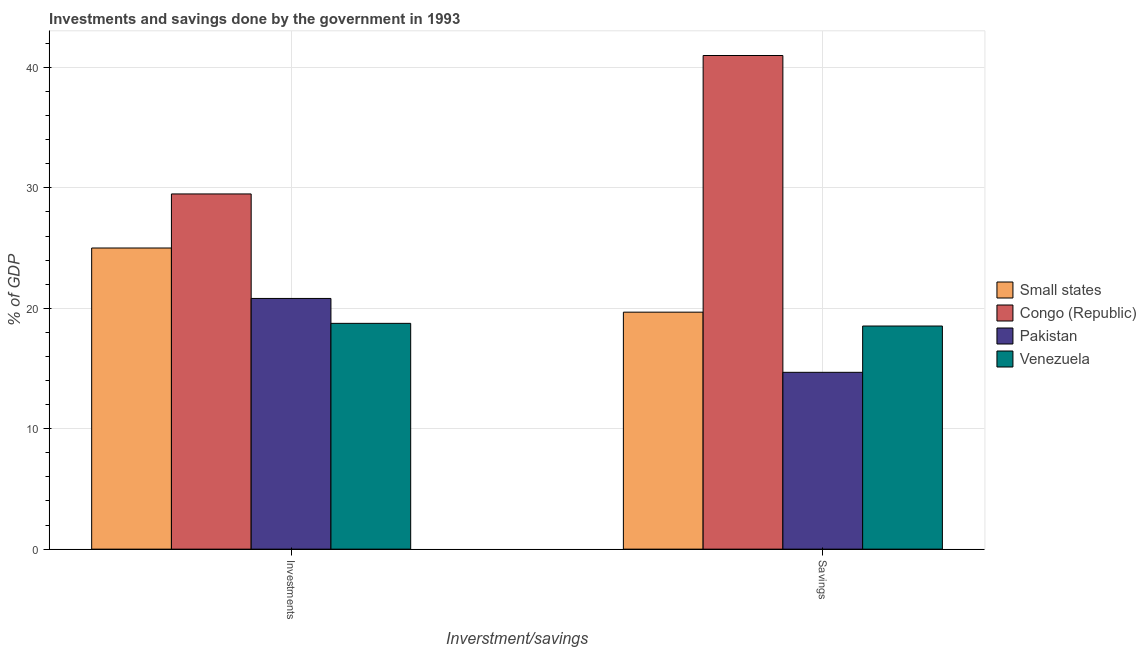How many groups of bars are there?
Your answer should be compact. 2. Are the number of bars per tick equal to the number of legend labels?
Make the answer very short. Yes. How many bars are there on the 1st tick from the left?
Your response must be concise. 4. How many bars are there on the 2nd tick from the right?
Make the answer very short. 4. What is the label of the 1st group of bars from the left?
Ensure brevity in your answer.  Investments. What is the savings of government in Small states?
Your answer should be compact. 19.68. Across all countries, what is the maximum investments of government?
Your answer should be compact. 29.5. Across all countries, what is the minimum savings of government?
Give a very brief answer. 14.68. In which country was the savings of government maximum?
Offer a terse response. Congo (Republic). What is the total investments of government in the graph?
Your answer should be compact. 94.07. What is the difference between the investments of government in Small states and that in Pakistan?
Offer a terse response. 4.19. What is the difference between the savings of government in Small states and the investments of government in Congo (Republic)?
Provide a succinct answer. -9.82. What is the average investments of government per country?
Provide a succinct answer. 23.52. What is the difference between the savings of government and investments of government in Congo (Republic)?
Provide a short and direct response. 11.5. In how many countries, is the savings of government greater than 30 %?
Provide a succinct answer. 1. What is the ratio of the investments of government in Venezuela to that in Small states?
Your response must be concise. 0.75. Is the investments of government in Small states less than that in Pakistan?
Ensure brevity in your answer.  No. What does the 4th bar from the left in Savings represents?
Provide a short and direct response. Venezuela. What does the 2nd bar from the right in Savings represents?
Your response must be concise. Pakistan. How many countries are there in the graph?
Your answer should be compact. 4. What is the difference between two consecutive major ticks on the Y-axis?
Make the answer very short. 10. Where does the legend appear in the graph?
Provide a short and direct response. Center right. How many legend labels are there?
Offer a very short reply. 4. How are the legend labels stacked?
Provide a short and direct response. Vertical. What is the title of the graph?
Your response must be concise. Investments and savings done by the government in 1993. What is the label or title of the X-axis?
Your answer should be compact. Inverstment/savings. What is the label or title of the Y-axis?
Give a very brief answer. % of GDP. What is the % of GDP of Small states in Investments?
Ensure brevity in your answer.  25.01. What is the % of GDP in Congo (Republic) in Investments?
Ensure brevity in your answer.  29.5. What is the % of GDP in Pakistan in Investments?
Your answer should be very brief. 20.82. What is the % of GDP of Venezuela in Investments?
Offer a very short reply. 18.75. What is the % of GDP of Small states in Savings?
Keep it short and to the point. 19.68. What is the % of GDP in Congo (Republic) in Savings?
Keep it short and to the point. 40.99. What is the % of GDP of Pakistan in Savings?
Keep it short and to the point. 14.68. What is the % of GDP in Venezuela in Savings?
Your answer should be compact. 18.53. Across all Inverstment/savings, what is the maximum % of GDP of Small states?
Ensure brevity in your answer.  25.01. Across all Inverstment/savings, what is the maximum % of GDP in Congo (Republic)?
Offer a terse response. 40.99. Across all Inverstment/savings, what is the maximum % of GDP in Pakistan?
Offer a terse response. 20.82. Across all Inverstment/savings, what is the maximum % of GDP in Venezuela?
Ensure brevity in your answer.  18.75. Across all Inverstment/savings, what is the minimum % of GDP of Small states?
Keep it short and to the point. 19.68. Across all Inverstment/savings, what is the minimum % of GDP of Congo (Republic)?
Keep it short and to the point. 29.5. Across all Inverstment/savings, what is the minimum % of GDP of Pakistan?
Keep it short and to the point. 14.68. Across all Inverstment/savings, what is the minimum % of GDP of Venezuela?
Offer a terse response. 18.53. What is the total % of GDP in Small states in the graph?
Make the answer very short. 44.69. What is the total % of GDP in Congo (Republic) in the graph?
Your response must be concise. 70.49. What is the total % of GDP in Pakistan in the graph?
Ensure brevity in your answer.  35.5. What is the total % of GDP in Venezuela in the graph?
Provide a short and direct response. 37.28. What is the difference between the % of GDP of Small states in Investments and that in Savings?
Ensure brevity in your answer.  5.33. What is the difference between the % of GDP in Congo (Republic) in Investments and that in Savings?
Your response must be concise. -11.5. What is the difference between the % of GDP in Pakistan in Investments and that in Savings?
Your answer should be compact. 6.13. What is the difference between the % of GDP of Venezuela in Investments and that in Savings?
Your answer should be compact. 0.22. What is the difference between the % of GDP of Small states in Investments and the % of GDP of Congo (Republic) in Savings?
Provide a succinct answer. -15.98. What is the difference between the % of GDP in Small states in Investments and the % of GDP in Pakistan in Savings?
Provide a short and direct response. 10.32. What is the difference between the % of GDP in Small states in Investments and the % of GDP in Venezuela in Savings?
Offer a terse response. 6.48. What is the difference between the % of GDP in Congo (Republic) in Investments and the % of GDP in Pakistan in Savings?
Keep it short and to the point. 14.81. What is the difference between the % of GDP in Congo (Republic) in Investments and the % of GDP in Venezuela in Savings?
Provide a short and direct response. 10.97. What is the difference between the % of GDP in Pakistan in Investments and the % of GDP in Venezuela in Savings?
Your answer should be very brief. 2.29. What is the average % of GDP of Small states per Inverstment/savings?
Offer a terse response. 22.34. What is the average % of GDP in Congo (Republic) per Inverstment/savings?
Keep it short and to the point. 35.24. What is the average % of GDP of Pakistan per Inverstment/savings?
Provide a succinct answer. 17.75. What is the average % of GDP of Venezuela per Inverstment/savings?
Give a very brief answer. 18.64. What is the difference between the % of GDP of Small states and % of GDP of Congo (Republic) in Investments?
Your answer should be compact. -4.49. What is the difference between the % of GDP in Small states and % of GDP in Pakistan in Investments?
Your answer should be very brief. 4.19. What is the difference between the % of GDP in Small states and % of GDP in Venezuela in Investments?
Offer a very short reply. 6.26. What is the difference between the % of GDP of Congo (Republic) and % of GDP of Pakistan in Investments?
Ensure brevity in your answer.  8.68. What is the difference between the % of GDP of Congo (Republic) and % of GDP of Venezuela in Investments?
Your answer should be compact. 10.75. What is the difference between the % of GDP in Pakistan and % of GDP in Venezuela in Investments?
Offer a very short reply. 2.07. What is the difference between the % of GDP of Small states and % of GDP of Congo (Republic) in Savings?
Give a very brief answer. -21.31. What is the difference between the % of GDP of Small states and % of GDP of Pakistan in Savings?
Give a very brief answer. 5. What is the difference between the % of GDP in Small states and % of GDP in Venezuela in Savings?
Make the answer very short. 1.15. What is the difference between the % of GDP in Congo (Republic) and % of GDP in Pakistan in Savings?
Your answer should be very brief. 26.31. What is the difference between the % of GDP in Congo (Republic) and % of GDP in Venezuela in Savings?
Give a very brief answer. 22.46. What is the difference between the % of GDP in Pakistan and % of GDP in Venezuela in Savings?
Offer a very short reply. -3.84. What is the ratio of the % of GDP of Small states in Investments to that in Savings?
Give a very brief answer. 1.27. What is the ratio of the % of GDP in Congo (Republic) in Investments to that in Savings?
Your response must be concise. 0.72. What is the ratio of the % of GDP in Pakistan in Investments to that in Savings?
Your answer should be very brief. 1.42. What is the ratio of the % of GDP of Venezuela in Investments to that in Savings?
Your answer should be compact. 1.01. What is the difference between the highest and the second highest % of GDP in Small states?
Offer a terse response. 5.33. What is the difference between the highest and the second highest % of GDP in Congo (Republic)?
Offer a terse response. 11.5. What is the difference between the highest and the second highest % of GDP in Pakistan?
Provide a short and direct response. 6.13. What is the difference between the highest and the second highest % of GDP of Venezuela?
Make the answer very short. 0.22. What is the difference between the highest and the lowest % of GDP of Small states?
Provide a short and direct response. 5.33. What is the difference between the highest and the lowest % of GDP in Congo (Republic)?
Make the answer very short. 11.5. What is the difference between the highest and the lowest % of GDP in Pakistan?
Provide a short and direct response. 6.13. What is the difference between the highest and the lowest % of GDP of Venezuela?
Make the answer very short. 0.22. 